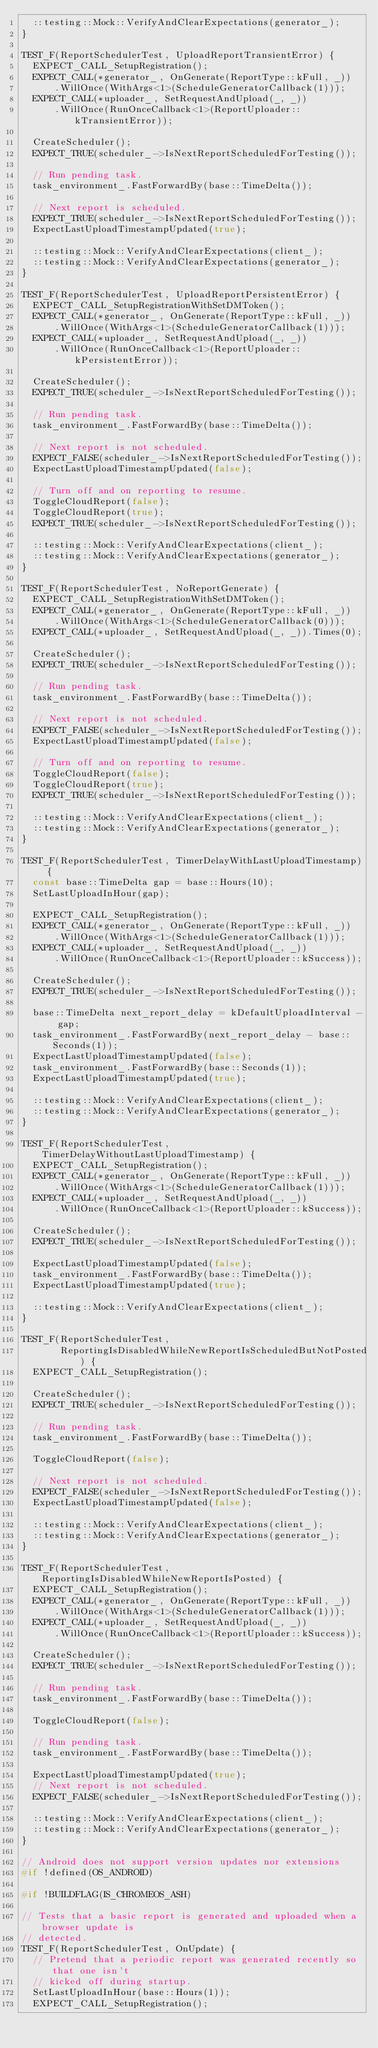Convert code to text. <code><loc_0><loc_0><loc_500><loc_500><_C++_>  ::testing::Mock::VerifyAndClearExpectations(generator_);
}

TEST_F(ReportSchedulerTest, UploadReportTransientError) {
  EXPECT_CALL_SetupRegistration();
  EXPECT_CALL(*generator_, OnGenerate(ReportType::kFull, _))
      .WillOnce(WithArgs<1>(ScheduleGeneratorCallback(1)));
  EXPECT_CALL(*uploader_, SetRequestAndUpload(_, _))
      .WillOnce(RunOnceCallback<1>(ReportUploader::kTransientError));

  CreateScheduler();
  EXPECT_TRUE(scheduler_->IsNextReportScheduledForTesting());

  // Run pending task.
  task_environment_.FastForwardBy(base::TimeDelta());

  // Next report is scheduled.
  EXPECT_TRUE(scheduler_->IsNextReportScheduledForTesting());
  ExpectLastUploadTimestampUpdated(true);

  ::testing::Mock::VerifyAndClearExpectations(client_);
  ::testing::Mock::VerifyAndClearExpectations(generator_);
}

TEST_F(ReportSchedulerTest, UploadReportPersistentError) {
  EXPECT_CALL_SetupRegistrationWithSetDMToken();
  EXPECT_CALL(*generator_, OnGenerate(ReportType::kFull, _))
      .WillOnce(WithArgs<1>(ScheduleGeneratorCallback(1)));
  EXPECT_CALL(*uploader_, SetRequestAndUpload(_, _))
      .WillOnce(RunOnceCallback<1>(ReportUploader::kPersistentError));

  CreateScheduler();
  EXPECT_TRUE(scheduler_->IsNextReportScheduledForTesting());

  // Run pending task.
  task_environment_.FastForwardBy(base::TimeDelta());

  // Next report is not scheduled.
  EXPECT_FALSE(scheduler_->IsNextReportScheduledForTesting());
  ExpectLastUploadTimestampUpdated(false);

  // Turn off and on reporting to resume.
  ToggleCloudReport(false);
  ToggleCloudReport(true);
  EXPECT_TRUE(scheduler_->IsNextReportScheduledForTesting());

  ::testing::Mock::VerifyAndClearExpectations(client_);
  ::testing::Mock::VerifyAndClearExpectations(generator_);
}

TEST_F(ReportSchedulerTest, NoReportGenerate) {
  EXPECT_CALL_SetupRegistrationWithSetDMToken();
  EXPECT_CALL(*generator_, OnGenerate(ReportType::kFull, _))
      .WillOnce(WithArgs<1>(ScheduleGeneratorCallback(0)));
  EXPECT_CALL(*uploader_, SetRequestAndUpload(_, _)).Times(0);

  CreateScheduler();
  EXPECT_TRUE(scheduler_->IsNextReportScheduledForTesting());

  // Run pending task.
  task_environment_.FastForwardBy(base::TimeDelta());

  // Next report is not scheduled.
  EXPECT_FALSE(scheduler_->IsNextReportScheduledForTesting());
  ExpectLastUploadTimestampUpdated(false);

  // Turn off and on reporting to resume.
  ToggleCloudReport(false);
  ToggleCloudReport(true);
  EXPECT_TRUE(scheduler_->IsNextReportScheduledForTesting());

  ::testing::Mock::VerifyAndClearExpectations(client_);
  ::testing::Mock::VerifyAndClearExpectations(generator_);
}

TEST_F(ReportSchedulerTest, TimerDelayWithLastUploadTimestamp) {
  const base::TimeDelta gap = base::Hours(10);
  SetLastUploadInHour(gap);

  EXPECT_CALL_SetupRegistration();
  EXPECT_CALL(*generator_, OnGenerate(ReportType::kFull, _))
      .WillOnce(WithArgs<1>(ScheduleGeneratorCallback(1)));
  EXPECT_CALL(*uploader_, SetRequestAndUpload(_, _))
      .WillOnce(RunOnceCallback<1>(ReportUploader::kSuccess));

  CreateScheduler();
  EXPECT_TRUE(scheduler_->IsNextReportScheduledForTesting());

  base::TimeDelta next_report_delay = kDefaultUploadInterval - gap;
  task_environment_.FastForwardBy(next_report_delay - base::Seconds(1));
  ExpectLastUploadTimestampUpdated(false);
  task_environment_.FastForwardBy(base::Seconds(1));
  ExpectLastUploadTimestampUpdated(true);

  ::testing::Mock::VerifyAndClearExpectations(client_);
  ::testing::Mock::VerifyAndClearExpectations(generator_);
}

TEST_F(ReportSchedulerTest, TimerDelayWithoutLastUploadTimestamp) {
  EXPECT_CALL_SetupRegistration();
  EXPECT_CALL(*generator_, OnGenerate(ReportType::kFull, _))
      .WillOnce(WithArgs<1>(ScheduleGeneratorCallback(1)));
  EXPECT_CALL(*uploader_, SetRequestAndUpload(_, _))
      .WillOnce(RunOnceCallback<1>(ReportUploader::kSuccess));

  CreateScheduler();
  EXPECT_TRUE(scheduler_->IsNextReportScheduledForTesting());

  ExpectLastUploadTimestampUpdated(false);
  task_environment_.FastForwardBy(base::TimeDelta());
  ExpectLastUploadTimestampUpdated(true);

  ::testing::Mock::VerifyAndClearExpectations(client_);
}

TEST_F(ReportSchedulerTest,
       ReportingIsDisabledWhileNewReportIsScheduledButNotPosted) {
  EXPECT_CALL_SetupRegistration();

  CreateScheduler();
  EXPECT_TRUE(scheduler_->IsNextReportScheduledForTesting());

  // Run pending task.
  task_environment_.FastForwardBy(base::TimeDelta());

  ToggleCloudReport(false);

  // Next report is not scheduled.
  EXPECT_FALSE(scheduler_->IsNextReportScheduledForTesting());
  ExpectLastUploadTimestampUpdated(false);

  ::testing::Mock::VerifyAndClearExpectations(client_);
  ::testing::Mock::VerifyAndClearExpectations(generator_);
}

TEST_F(ReportSchedulerTest, ReportingIsDisabledWhileNewReportIsPosted) {
  EXPECT_CALL_SetupRegistration();
  EXPECT_CALL(*generator_, OnGenerate(ReportType::kFull, _))
      .WillOnce(WithArgs<1>(ScheduleGeneratorCallback(1)));
  EXPECT_CALL(*uploader_, SetRequestAndUpload(_, _))
      .WillOnce(RunOnceCallback<1>(ReportUploader::kSuccess));

  CreateScheduler();
  EXPECT_TRUE(scheduler_->IsNextReportScheduledForTesting());

  // Run pending task.
  task_environment_.FastForwardBy(base::TimeDelta());

  ToggleCloudReport(false);

  // Run pending task.
  task_environment_.FastForwardBy(base::TimeDelta());

  ExpectLastUploadTimestampUpdated(true);
  // Next report is not scheduled.
  EXPECT_FALSE(scheduler_->IsNextReportScheduledForTesting());

  ::testing::Mock::VerifyAndClearExpectations(client_);
  ::testing::Mock::VerifyAndClearExpectations(generator_);
}

// Android does not support version updates nor extensions
#if !defined(OS_ANDROID)

#if !BUILDFLAG(IS_CHROMEOS_ASH)

// Tests that a basic report is generated and uploaded when a browser update is
// detected.
TEST_F(ReportSchedulerTest, OnUpdate) {
  // Pretend that a periodic report was generated recently so that one isn't
  // kicked off during startup.
  SetLastUploadInHour(base::Hours(1));
  EXPECT_CALL_SetupRegistration();</code> 